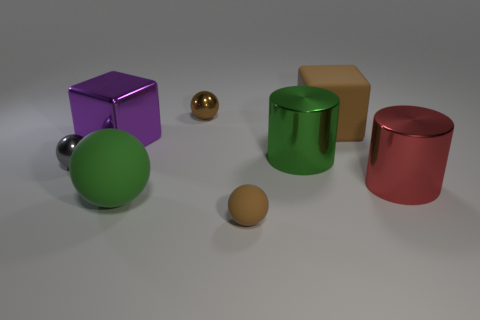How many rubber things are big cyan spheres or large green things?
Your answer should be compact. 1. How many green things are left of the tiny shiny thing left of the big rubber object that is on the left side of the tiny matte object?
Your answer should be compact. 0. Does the shiny object that is to the left of the purple object have the same size as the brown thing that is in front of the large brown block?
Make the answer very short. Yes. There is another large object that is the same shape as the green metal thing; what material is it?
Make the answer very short. Metal. What number of big things are either yellow metal cylinders or brown matte blocks?
Provide a succinct answer. 1. What material is the brown cube?
Make the answer very short. Rubber. There is a thing that is both to the right of the green rubber object and on the left side of the tiny brown rubber ball; what is it made of?
Provide a succinct answer. Metal. Do the tiny rubber sphere and the small metal ball right of the big matte sphere have the same color?
Your response must be concise. Yes. What material is the green thing that is the same size as the green ball?
Your response must be concise. Metal. Is there a big gray thing that has the same material as the gray sphere?
Provide a succinct answer. No. 